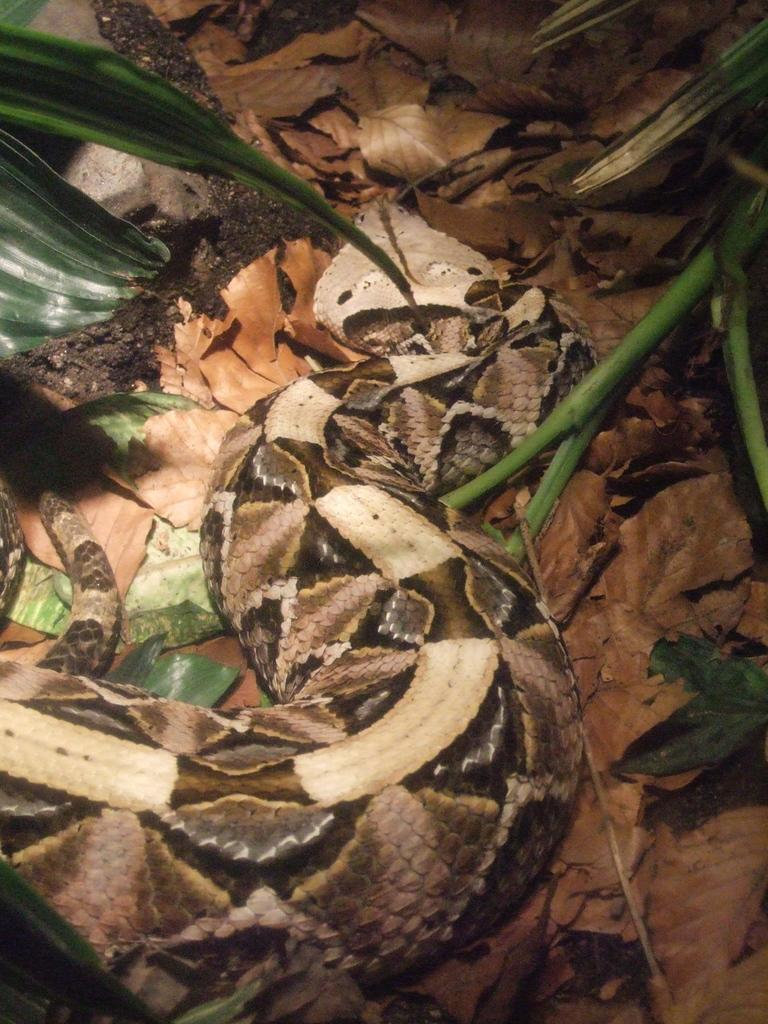What is the main subject in the center of the image? There is a snake in the center of the image. What can be seen in the background of the image? There are dry leaves, plants, and sand visible in the background of the image. What type of ear is visible in the image? There is no ear present in the image; it features a snake and background elements. 